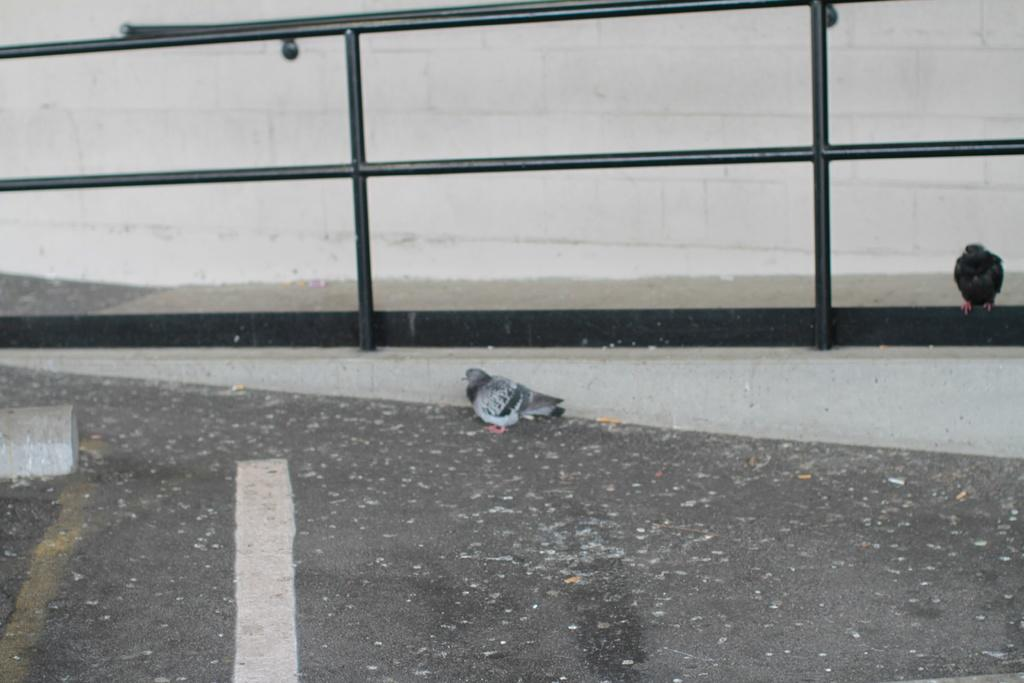How many pigeons are in the image? There are two pigeons in the image. Where is the first pigeon located? One pigeon is standing on the road. Where is the second pigeon located? The other pigeon is standing at the fence. What can be seen in the background of the image? There is a wall in the image. What type of operation is the pigeon performing on the face in the image? There is no operation or face present in the image; it features two pigeons and a wall. Can you tell me how many beetles are crawling on the pigeons in the image? There are no beetles present in the image; it only shows two pigeons and a wall. 